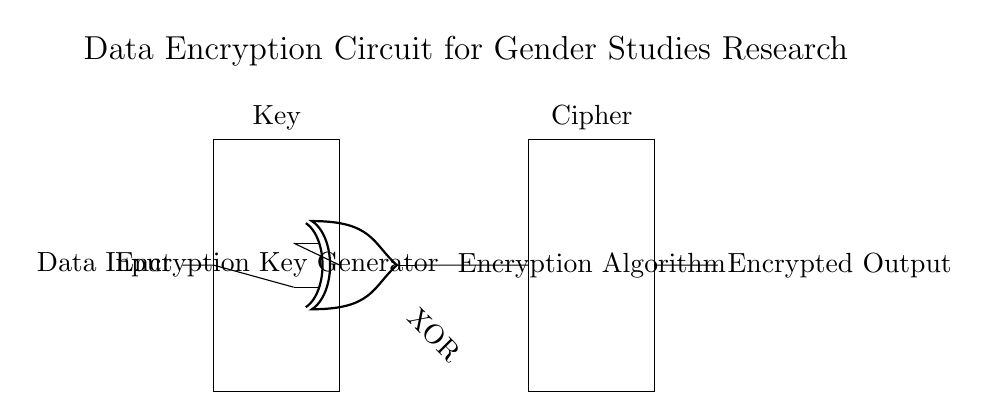What is the primary function of this circuit? The primary function is to encrypt data for protecting sensitive information in gender studies research. This is evident from the title labeled above the circuit and the presence of key components such as an encryption key generator and an encryption algorithm.
Answer: Data encryption What type of gate is used for encryption? The circuit utilizes an XOR gate for the encryption process, as indicated by the symbol labeled in the diagram. An XOR gate is commonly used in encryption algorithms for its property of producing a true output when the inputs differ.
Answer: XOR How many main components are in this circuit? The circuit contains three main components: the encryption key generator, the XOR gate, and the encryption algorithm block. Each component is distinctly labeled, allowing for easy identification.
Answer: Three What is the output of the XOR gate? The output of the XOR gate is referred to as the cipher, which is the encrypted output. This is indicated by the labeling connected to the encryption algorithm and the output designation marked in the diagram.
Answer: Cipher What is the role of the encryption key generator? The role of the encryption key generator is to create a unique key that is utilized in the encryption process. This component is essential for ensuring that the data can be securely encrypted and later decrypted with the correct key.
Answer: Create key How does the XOR gate receive its inputs? The XOR gate receives its inputs from two sources: the encryption key generator and the data input line. The connections leading to the gate clearly show that it integrates both the encryption key and actual data for processing.
Answer: Two inputs 